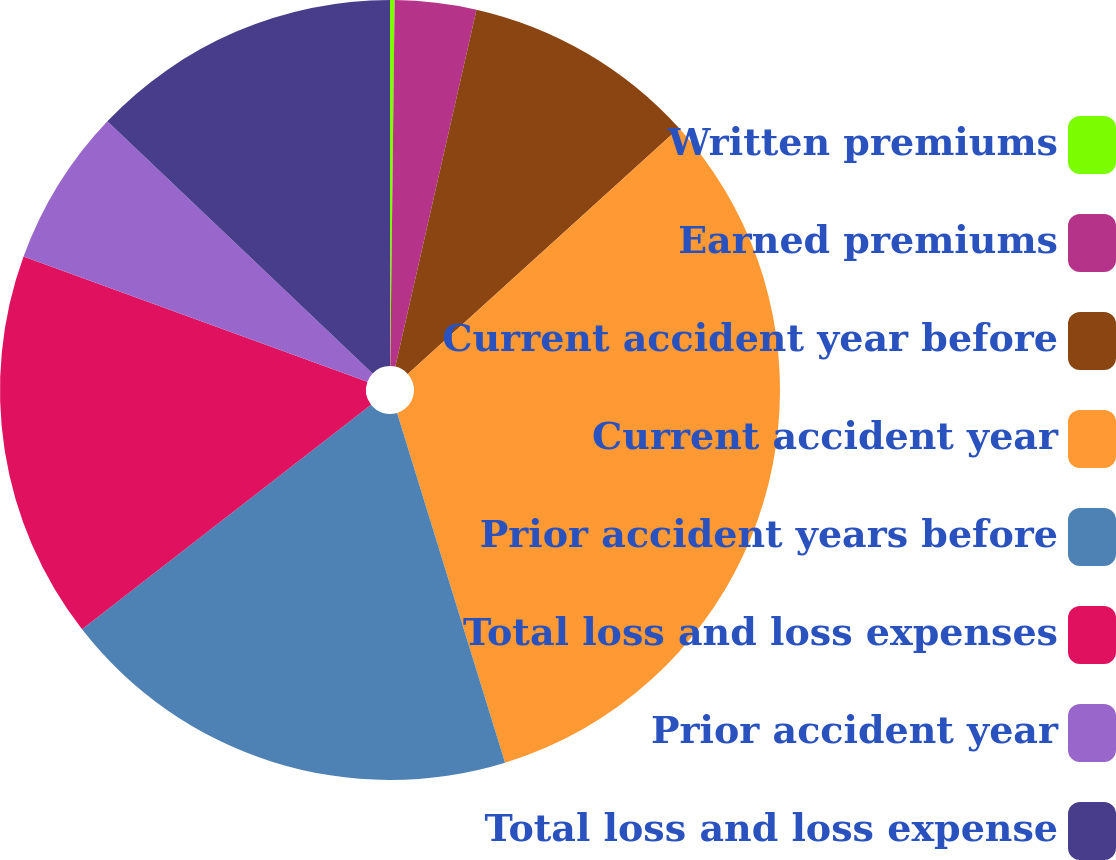Convert chart. <chart><loc_0><loc_0><loc_500><loc_500><pie_chart><fcel>Written premiums<fcel>Earned premiums<fcel>Current accident year before<fcel>Current accident year<fcel>Prior accident years before<fcel>Total loss and loss expenses<fcel>Prior accident year<fcel>Total loss and loss expense<nl><fcel>0.19%<fcel>3.37%<fcel>9.72%<fcel>31.95%<fcel>19.25%<fcel>16.07%<fcel>6.54%<fcel>12.9%<nl></chart> 